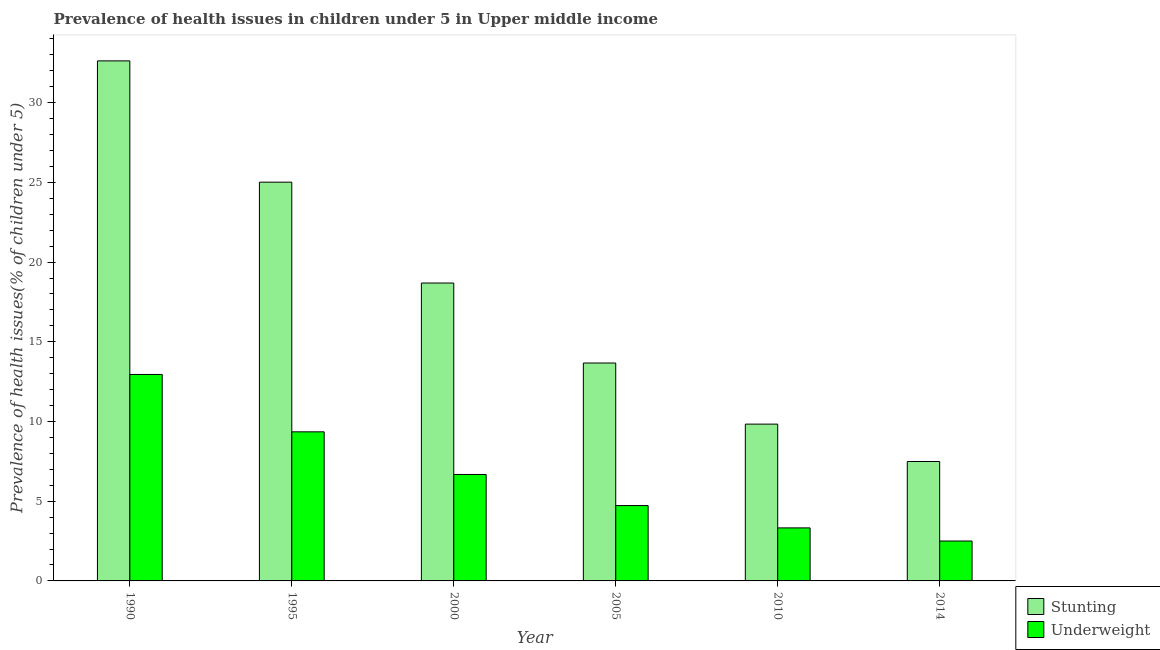Are the number of bars on each tick of the X-axis equal?
Give a very brief answer. Yes. How many bars are there on the 3rd tick from the left?
Your answer should be compact. 2. How many bars are there on the 4th tick from the right?
Keep it short and to the point. 2. In how many cases, is the number of bars for a given year not equal to the number of legend labels?
Provide a short and direct response. 0. What is the percentage of stunted children in 2000?
Provide a short and direct response. 18.69. Across all years, what is the maximum percentage of underweight children?
Give a very brief answer. 12.95. Across all years, what is the minimum percentage of underweight children?
Make the answer very short. 2.5. What is the total percentage of stunted children in the graph?
Your answer should be very brief. 107.31. What is the difference between the percentage of underweight children in 1990 and that in 2014?
Your answer should be very brief. 10.45. What is the difference between the percentage of stunted children in 2014 and the percentage of underweight children in 2010?
Offer a very short reply. -2.35. What is the average percentage of stunted children per year?
Offer a very short reply. 17.89. What is the ratio of the percentage of underweight children in 1990 to that in 2010?
Keep it short and to the point. 3.89. What is the difference between the highest and the second highest percentage of underweight children?
Provide a succinct answer. 3.6. What is the difference between the highest and the lowest percentage of underweight children?
Provide a succinct answer. 10.45. What does the 1st bar from the left in 1990 represents?
Your answer should be very brief. Stunting. What does the 2nd bar from the right in 2005 represents?
Provide a succinct answer. Stunting. How many bars are there?
Ensure brevity in your answer.  12. How many years are there in the graph?
Give a very brief answer. 6. What is the difference between two consecutive major ticks on the Y-axis?
Your answer should be compact. 5. Are the values on the major ticks of Y-axis written in scientific E-notation?
Ensure brevity in your answer.  No. Does the graph contain any zero values?
Ensure brevity in your answer.  No. Where does the legend appear in the graph?
Keep it short and to the point. Bottom right. How many legend labels are there?
Provide a short and direct response. 2. How are the legend labels stacked?
Offer a very short reply. Vertical. What is the title of the graph?
Your answer should be compact. Prevalence of health issues in children under 5 in Upper middle income. Does "Non-pregnant women" appear as one of the legend labels in the graph?
Make the answer very short. No. What is the label or title of the Y-axis?
Make the answer very short. Prevalence of health issues(% of children under 5). What is the Prevalence of health issues(% of children under 5) in Stunting in 1990?
Make the answer very short. 32.62. What is the Prevalence of health issues(% of children under 5) in Underweight in 1990?
Your answer should be very brief. 12.95. What is the Prevalence of health issues(% of children under 5) of Stunting in 1995?
Make the answer very short. 25.01. What is the Prevalence of health issues(% of children under 5) in Underweight in 1995?
Make the answer very short. 9.35. What is the Prevalence of health issues(% of children under 5) in Stunting in 2000?
Provide a succinct answer. 18.69. What is the Prevalence of health issues(% of children under 5) in Underweight in 2000?
Provide a succinct answer. 6.68. What is the Prevalence of health issues(% of children under 5) of Stunting in 2005?
Offer a very short reply. 13.67. What is the Prevalence of health issues(% of children under 5) in Underweight in 2005?
Your response must be concise. 4.73. What is the Prevalence of health issues(% of children under 5) in Stunting in 2010?
Provide a succinct answer. 9.84. What is the Prevalence of health issues(% of children under 5) in Underweight in 2010?
Make the answer very short. 3.33. What is the Prevalence of health issues(% of children under 5) of Stunting in 2014?
Give a very brief answer. 7.49. What is the Prevalence of health issues(% of children under 5) of Underweight in 2014?
Make the answer very short. 2.5. Across all years, what is the maximum Prevalence of health issues(% of children under 5) of Stunting?
Offer a very short reply. 32.62. Across all years, what is the maximum Prevalence of health issues(% of children under 5) of Underweight?
Offer a very short reply. 12.95. Across all years, what is the minimum Prevalence of health issues(% of children under 5) of Stunting?
Your answer should be very brief. 7.49. Across all years, what is the minimum Prevalence of health issues(% of children under 5) of Underweight?
Ensure brevity in your answer.  2.5. What is the total Prevalence of health issues(% of children under 5) of Stunting in the graph?
Give a very brief answer. 107.31. What is the total Prevalence of health issues(% of children under 5) of Underweight in the graph?
Ensure brevity in your answer.  39.53. What is the difference between the Prevalence of health issues(% of children under 5) of Stunting in 1990 and that in 1995?
Your response must be concise. 7.61. What is the difference between the Prevalence of health issues(% of children under 5) of Underweight in 1990 and that in 1995?
Provide a succinct answer. 3.6. What is the difference between the Prevalence of health issues(% of children under 5) in Stunting in 1990 and that in 2000?
Offer a terse response. 13.93. What is the difference between the Prevalence of health issues(% of children under 5) of Underweight in 1990 and that in 2000?
Offer a very short reply. 6.27. What is the difference between the Prevalence of health issues(% of children under 5) of Stunting in 1990 and that in 2005?
Your response must be concise. 18.95. What is the difference between the Prevalence of health issues(% of children under 5) in Underweight in 1990 and that in 2005?
Keep it short and to the point. 8.22. What is the difference between the Prevalence of health issues(% of children under 5) of Stunting in 1990 and that in 2010?
Give a very brief answer. 22.78. What is the difference between the Prevalence of health issues(% of children under 5) in Underweight in 1990 and that in 2010?
Your answer should be compact. 9.62. What is the difference between the Prevalence of health issues(% of children under 5) of Stunting in 1990 and that in 2014?
Provide a short and direct response. 25.13. What is the difference between the Prevalence of health issues(% of children under 5) of Underweight in 1990 and that in 2014?
Give a very brief answer. 10.45. What is the difference between the Prevalence of health issues(% of children under 5) of Stunting in 1995 and that in 2000?
Provide a short and direct response. 6.33. What is the difference between the Prevalence of health issues(% of children under 5) of Underweight in 1995 and that in 2000?
Keep it short and to the point. 2.68. What is the difference between the Prevalence of health issues(% of children under 5) in Stunting in 1995 and that in 2005?
Offer a terse response. 11.34. What is the difference between the Prevalence of health issues(% of children under 5) in Underweight in 1995 and that in 2005?
Provide a short and direct response. 4.62. What is the difference between the Prevalence of health issues(% of children under 5) of Stunting in 1995 and that in 2010?
Keep it short and to the point. 15.18. What is the difference between the Prevalence of health issues(% of children under 5) in Underweight in 1995 and that in 2010?
Provide a short and direct response. 6.03. What is the difference between the Prevalence of health issues(% of children under 5) in Stunting in 1995 and that in 2014?
Your response must be concise. 17.52. What is the difference between the Prevalence of health issues(% of children under 5) in Underweight in 1995 and that in 2014?
Ensure brevity in your answer.  6.85. What is the difference between the Prevalence of health issues(% of children under 5) of Stunting in 2000 and that in 2005?
Provide a succinct answer. 5.02. What is the difference between the Prevalence of health issues(% of children under 5) of Underweight in 2000 and that in 2005?
Ensure brevity in your answer.  1.95. What is the difference between the Prevalence of health issues(% of children under 5) of Stunting in 2000 and that in 2010?
Your response must be concise. 8.85. What is the difference between the Prevalence of health issues(% of children under 5) in Underweight in 2000 and that in 2010?
Your response must be concise. 3.35. What is the difference between the Prevalence of health issues(% of children under 5) in Stunting in 2000 and that in 2014?
Your answer should be very brief. 11.2. What is the difference between the Prevalence of health issues(% of children under 5) in Underweight in 2000 and that in 2014?
Offer a very short reply. 4.17. What is the difference between the Prevalence of health issues(% of children under 5) in Stunting in 2005 and that in 2010?
Ensure brevity in your answer.  3.83. What is the difference between the Prevalence of health issues(% of children under 5) of Underweight in 2005 and that in 2010?
Give a very brief answer. 1.4. What is the difference between the Prevalence of health issues(% of children under 5) of Stunting in 2005 and that in 2014?
Your response must be concise. 6.18. What is the difference between the Prevalence of health issues(% of children under 5) in Underweight in 2005 and that in 2014?
Make the answer very short. 2.22. What is the difference between the Prevalence of health issues(% of children under 5) in Stunting in 2010 and that in 2014?
Ensure brevity in your answer.  2.35. What is the difference between the Prevalence of health issues(% of children under 5) of Underweight in 2010 and that in 2014?
Make the answer very short. 0.82. What is the difference between the Prevalence of health issues(% of children under 5) of Stunting in 1990 and the Prevalence of health issues(% of children under 5) of Underweight in 1995?
Give a very brief answer. 23.27. What is the difference between the Prevalence of health issues(% of children under 5) in Stunting in 1990 and the Prevalence of health issues(% of children under 5) in Underweight in 2000?
Ensure brevity in your answer.  25.94. What is the difference between the Prevalence of health issues(% of children under 5) in Stunting in 1990 and the Prevalence of health issues(% of children under 5) in Underweight in 2005?
Your answer should be very brief. 27.89. What is the difference between the Prevalence of health issues(% of children under 5) of Stunting in 1990 and the Prevalence of health issues(% of children under 5) of Underweight in 2010?
Keep it short and to the point. 29.29. What is the difference between the Prevalence of health issues(% of children under 5) in Stunting in 1990 and the Prevalence of health issues(% of children under 5) in Underweight in 2014?
Your answer should be compact. 30.12. What is the difference between the Prevalence of health issues(% of children under 5) in Stunting in 1995 and the Prevalence of health issues(% of children under 5) in Underweight in 2000?
Your answer should be very brief. 18.34. What is the difference between the Prevalence of health issues(% of children under 5) in Stunting in 1995 and the Prevalence of health issues(% of children under 5) in Underweight in 2005?
Keep it short and to the point. 20.28. What is the difference between the Prevalence of health issues(% of children under 5) in Stunting in 1995 and the Prevalence of health issues(% of children under 5) in Underweight in 2010?
Keep it short and to the point. 21.69. What is the difference between the Prevalence of health issues(% of children under 5) of Stunting in 1995 and the Prevalence of health issues(% of children under 5) of Underweight in 2014?
Your answer should be compact. 22.51. What is the difference between the Prevalence of health issues(% of children under 5) of Stunting in 2000 and the Prevalence of health issues(% of children under 5) of Underweight in 2005?
Ensure brevity in your answer.  13.96. What is the difference between the Prevalence of health issues(% of children under 5) in Stunting in 2000 and the Prevalence of health issues(% of children under 5) in Underweight in 2010?
Give a very brief answer. 15.36. What is the difference between the Prevalence of health issues(% of children under 5) in Stunting in 2000 and the Prevalence of health issues(% of children under 5) in Underweight in 2014?
Your answer should be very brief. 16.18. What is the difference between the Prevalence of health issues(% of children under 5) in Stunting in 2005 and the Prevalence of health issues(% of children under 5) in Underweight in 2010?
Ensure brevity in your answer.  10.34. What is the difference between the Prevalence of health issues(% of children under 5) of Stunting in 2005 and the Prevalence of health issues(% of children under 5) of Underweight in 2014?
Your response must be concise. 11.17. What is the difference between the Prevalence of health issues(% of children under 5) in Stunting in 2010 and the Prevalence of health issues(% of children under 5) in Underweight in 2014?
Make the answer very short. 7.33. What is the average Prevalence of health issues(% of children under 5) in Stunting per year?
Keep it short and to the point. 17.89. What is the average Prevalence of health issues(% of children under 5) of Underweight per year?
Keep it short and to the point. 6.59. In the year 1990, what is the difference between the Prevalence of health issues(% of children under 5) in Stunting and Prevalence of health issues(% of children under 5) in Underweight?
Provide a succinct answer. 19.67. In the year 1995, what is the difference between the Prevalence of health issues(% of children under 5) in Stunting and Prevalence of health issues(% of children under 5) in Underweight?
Provide a succinct answer. 15.66. In the year 2000, what is the difference between the Prevalence of health issues(% of children under 5) of Stunting and Prevalence of health issues(% of children under 5) of Underweight?
Provide a short and direct response. 12.01. In the year 2005, what is the difference between the Prevalence of health issues(% of children under 5) of Stunting and Prevalence of health issues(% of children under 5) of Underweight?
Offer a terse response. 8.94. In the year 2010, what is the difference between the Prevalence of health issues(% of children under 5) of Stunting and Prevalence of health issues(% of children under 5) of Underweight?
Ensure brevity in your answer.  6.51. In the year 2014, what is the difference between the Prevalence of health issues(% of children under 5) of Stunting and Prevalence of health issues(% of children under 5) of Underweight?
Keep it short and to the point. 4.99. What is the ratio of the Prevalence of health issues(% of children under 5) of Stunting in 1990 to that in 1995?
Keep it short and to the point. 1.3. What is the ratio of the Prevalence of health issues(% of children under 5) of Underweight in 1990 to that in 1995?
Your response must be concise. 1.38. What is the ratio of the Prevalence of health issues(% of children under 5) of Stunting in 1990 to that in 2000?
Your answer should be very brief. 1.75. What is the ratio of the Prevalence of health issues(% of children under 5) in Underweight in 1990 to that in 2000?
Provide a succinct answer. 1.94. What is the ratio of the Prevalence of health issues(% of children under 5) in Stunting in 1990 to that in 2005?
Offer a terse response. 2.39. What is the ratio of the Prevalence of health issues(% of children under 5) of Underweight in 1990 to that in 2005?
Ensure brevity in your answer.  2.74. What is the ratio of the Prevalence of health issues(% of children under 5) in Stunting in 1990 to that in 2010?
Keep it short and to the point. 3.32. What is the ratio of the Prevalence of health issues(% of children under 5) in Underweight in 1990 to that in 2010?
Give a very brief answer. 3.89. What is the ratio of the Prevalence of health issues(% of children under 5) in Stunting in 1990 to that in 2014?
Offer a very short reply. 4.35. What is the ratio of the Prevalence of health issues(% of children under 5) of Underweight in 1990 to that in 2014?
Provide a succinct answer. 5.17. What is the ratio of the Prevalence of health issues(% of children under 5) of Stunting in 1995 to that in 2000?
Make the answer very short. 1.34. What is the ratio of the Prevalence of health issues(% of children under 5) of Underweight in 1995 to that in 2000?
Make the answer very short. 1.4. What is the ratio of the Prevalence of health issues(% of children under 5) of Stunting in 1995 to that in 2005?
Keep it short and to the point. 1.83. What is the ratio of the Prevalence of health issues(% of children under 5) in Underweight in 1995 to that in 2005?
Keep it short and to the point. 1.98. What is the ratio of the Prevalence of health issues(% of children under 5) in Stunting in 1995 to that in 2010?
Your answer should be compact. 2.54. What is the ratio of the Prevalence of health issues(% of children under 5) of Underweight in 1995 to that in 2010?
Offer a very short reply. 2.81. What is the ratio of the Prevalence of health issues(% of children under 5) in Stunting in 1995 to that in 2014?
Your answer should be compact. 3.34. What is the ratio of the Prevalence of health issues(% of children under 5) of Underweight in 1995 to that in 2014?
Provide a succinct answer. 3.74. What is the ratio of the Prevalence of health issues(% of children under 5) in Stunting in 2000 to that in 2005?
Keep it short and to the point. 1.37. What is the ratio of the Prevalence of health issues(% of children under 5) in Underweight in 2000 to that in 2005?
Offer a terse response. 1.41. What is the ratio of the Prevalence of health issues(% of children under 5) of Stunting in 2000 to that in 2010?
Your response must be concise. 1.9. What is the ratio of the Prevalence of health issues(% of children under 5) in Underweight in 2000 to that in 2010?
Provide a short and direct response. 2.01. What is the ratio of the Prevalence of health issues(% of children under 5) of Stunting in 2000 to that in 2014?
Offer a very short reply. 2.49. What is the ratio of the Prevalence of health issues(% of children under 5) in Underweight in 2000 to that in 2014?
Provide a short and direct response. 2.67. What is the ratio of the Prevalence of health issues(% of children under 5) in Stunting in 2005 to that in 2010?
Make the answer very short. 1.39. What is the ratio of the Prevalence of health issues(% of children under 5) in Underweight in 2005 to that in 2010?
Ensure brevity in your answer.  1.42. What is the ratio of the Prevalence of health issues(% of children under 5) of Stunting in 2005 to that in 2014?
Make the answer very short. 1.82. What is the ratio of the Prevalence of health issues(% of children under 5) in Underweight in 2005 to that in 2014?
Offer a very short reply. 1.89. What is the ratio of the Prevalence of health issues(% of children under 5) of Stunting in 2010 to that in 2014?
Give a very brief answer. 1.31. What is the ratio of the Prevalence of health issues(% of children under 5) of Underweight in 2010 to that in 2014?
Offer a terse response. 1.33. What is the difference between the highest and the second highest Prevalence of health issues(% of children under 5) in Stunting?
Provide a short and direct response. 7.61. What is the difference between the highest and the second highest Prevalence of health issues(% of children under 5) of Underweight?
Your answer should be compact. 3.6. What is the difference between the highest and the lowest Prevalence of health issues(% of children under 5) of Stunting?
Give a very brief answer. 25.13. What is the difference between the highest and the lowest Prevalence of health issues(% of children under 5) in Underweight?
Your answer should be compact. 10.45. 